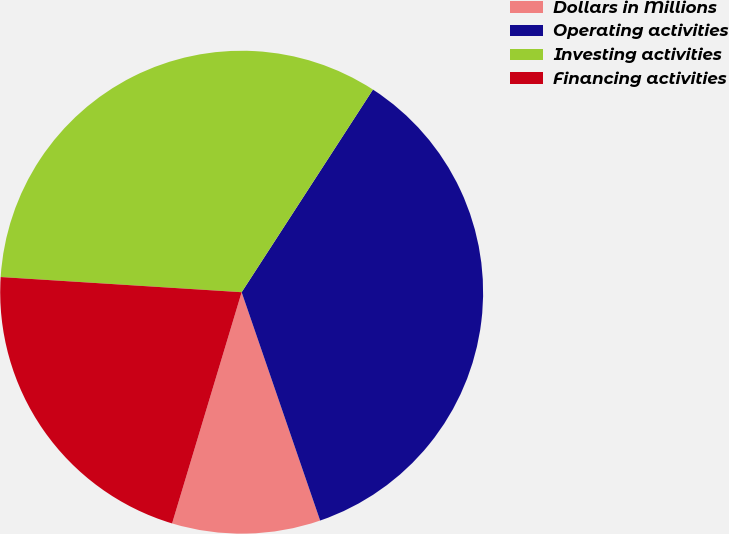Convert chart to OTSL. <chart><loc_0><loc_0><loc_500><loc_500><pie_chart><fcel>Dollars in Millions<fcel>Operating activities<fcel>Investing activities<fcel>Financing activities<nl><fcel>9.92%<fcel>35.58%<fcel>33.15%<fcel>21.35%<nl></chart> 